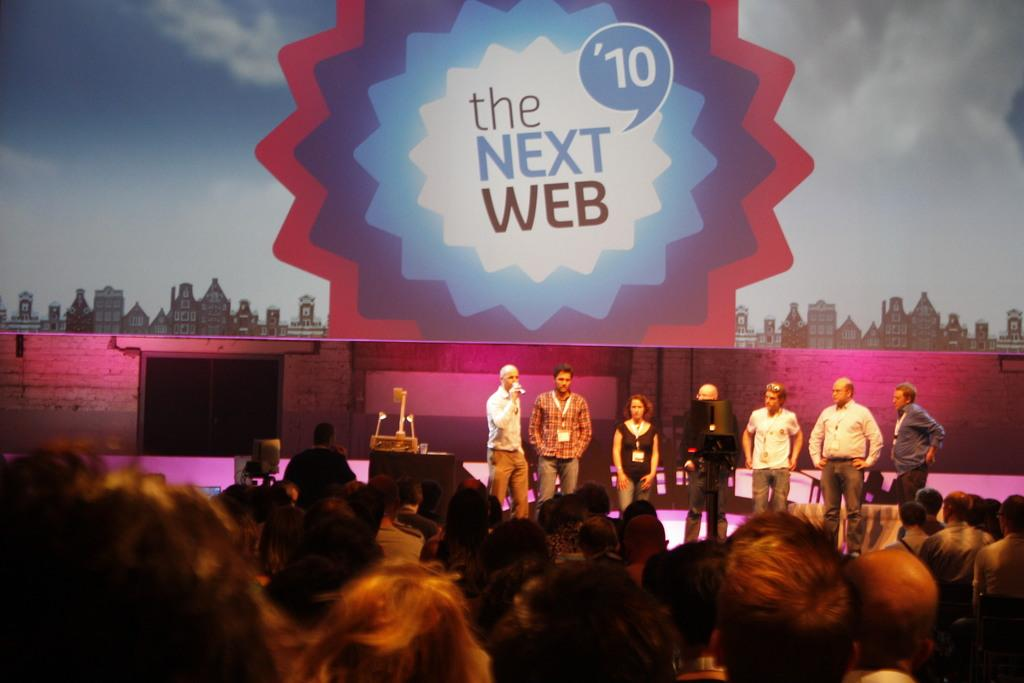How many people are in the image? There is a group of people in the image, but the exact number cannot be determined without more information. What can be seen in the background of the image? There is a banner in the background of the image. What caption is written on the banner in the image? There is no information provided about any caption on the banner, so we cannot answer this question. 